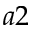<formula> <loc_0><loc_0><loc_500><loc_500>a 2</formula> 